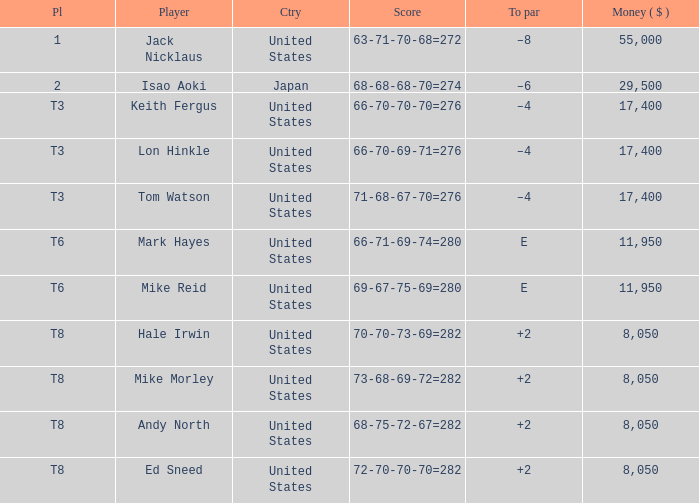What country has the score og 66-70-69-71=276? United States. 